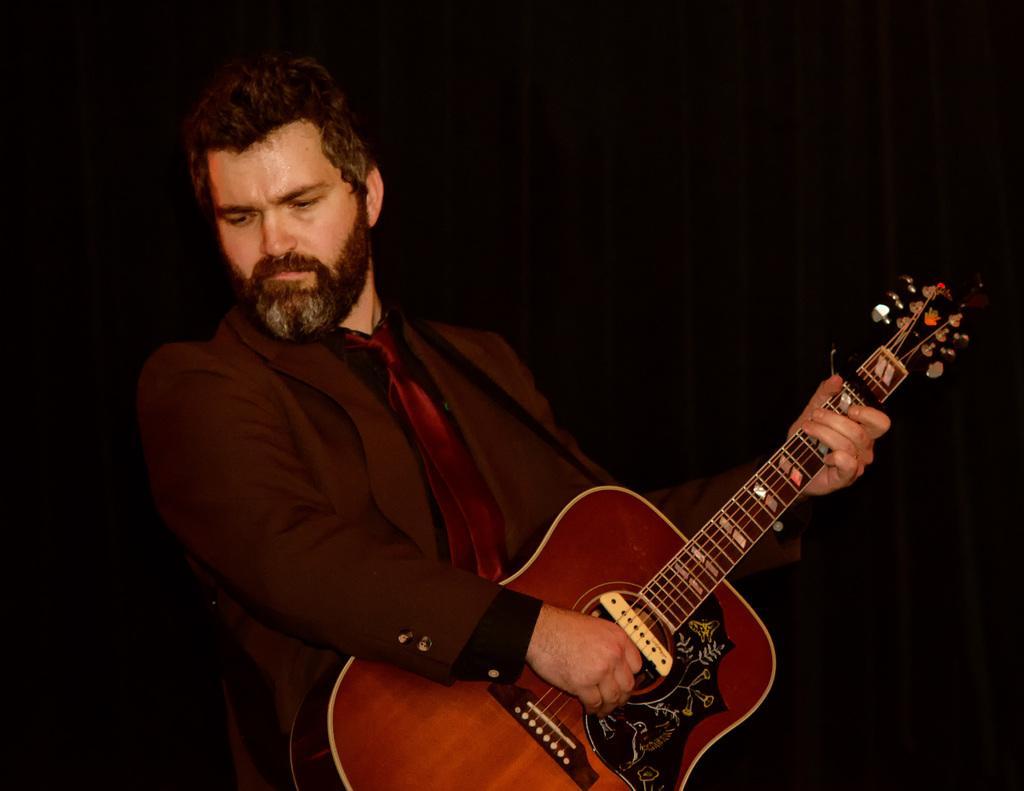Could you give a brief overview of what you see in this image? He is standing. He is playing a guitar. He is wearing suit and tie. 